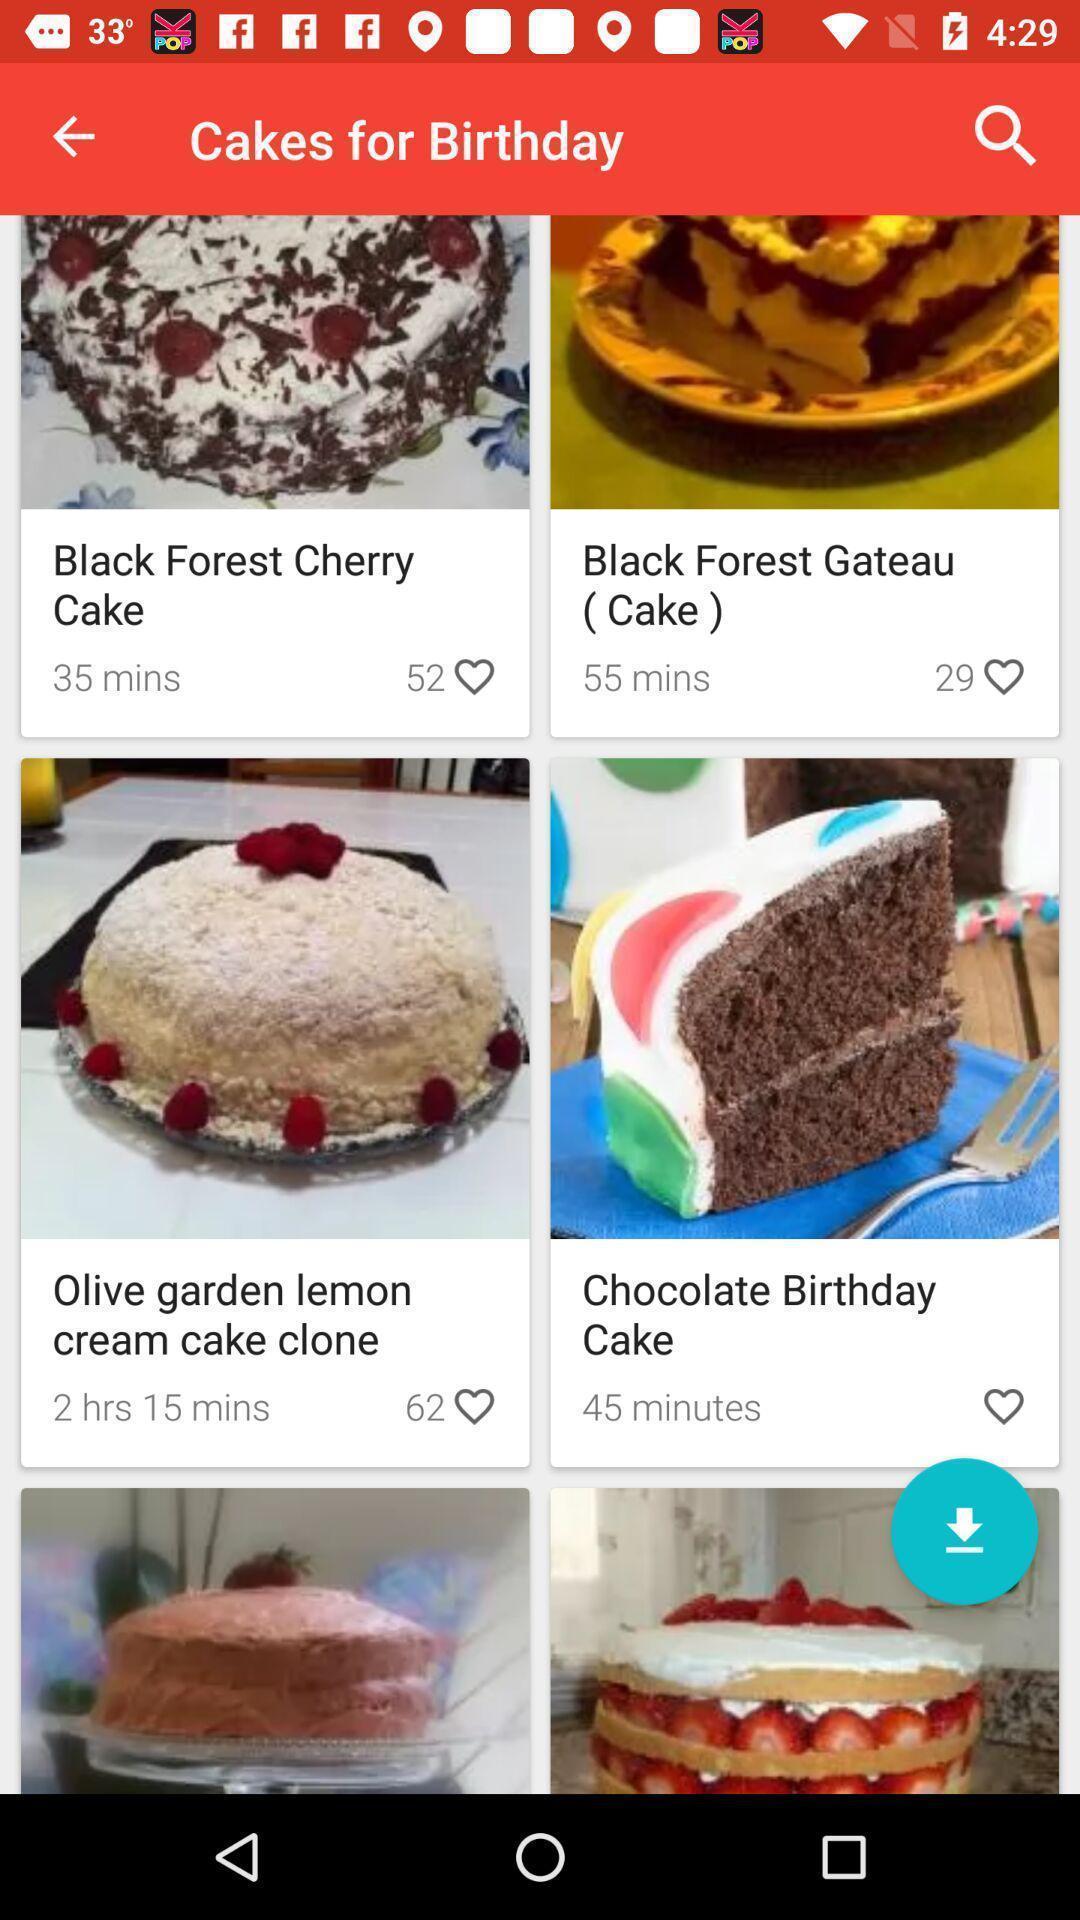Describe the content in this image. Search page showing results of cakes for birthday. 